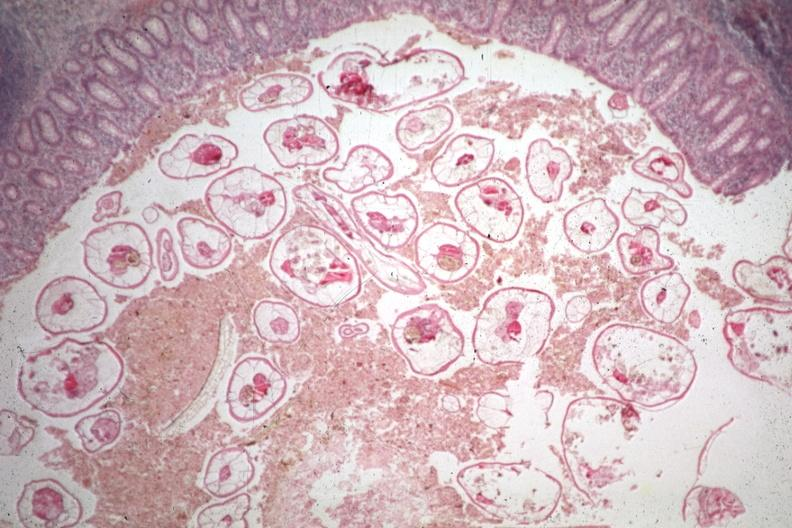what is present?
Answer the question using a single word or phrase. Appendix 